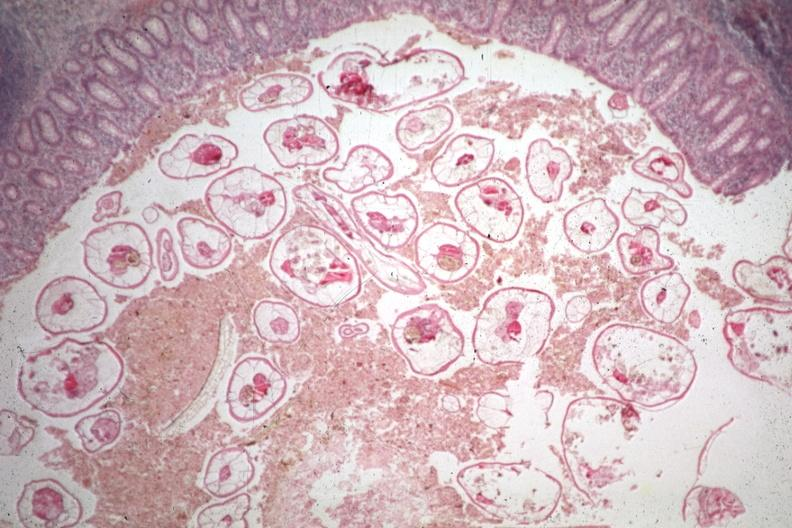what is present?
Answer the question using a single word or phrase. Appendix 